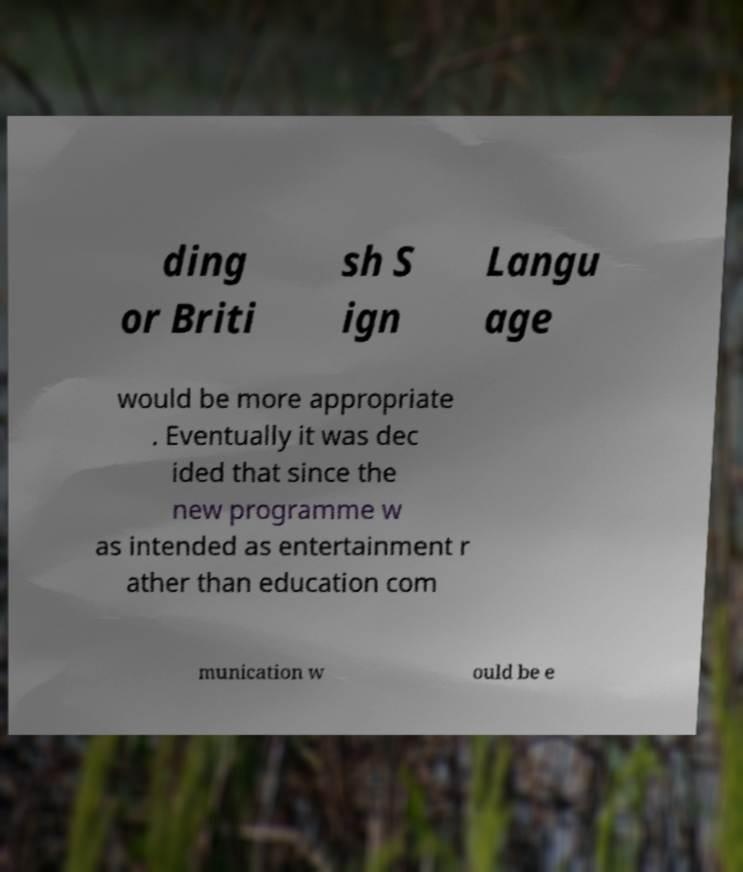What messages or text are displayed in this image? I need them in a readable, typed format. ding or Briti sh S ign Langu age would be more appropriate . Eventually it was dec ided that since the new programme w as intended as entertainment r ather than education com munication w ould be e 